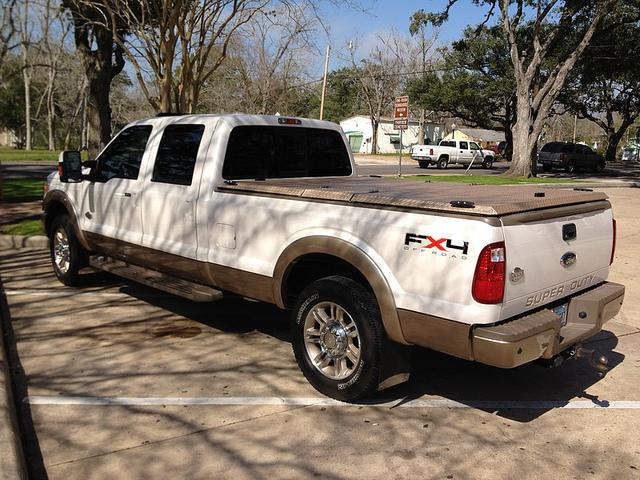What is the cover on the back of the truck called? Please explain your reasoning. tonneau cover. This is the correct term per google search and wikipedia. 